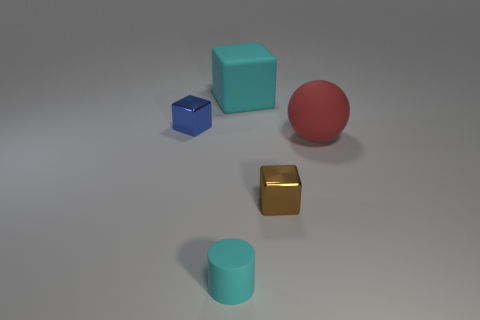Subtract all small cubes. How many cubes are left? 1 Add 4 large rubber objects. How many objects exist? 9 Subtract all cylinders. How many objects are left? 4 Subtract 1 cylinders. How many cylinders are left? 0 Subtract all blue blocks. How many yellow balls are left? 0 Subtract all tiny brown rubber cylinders. Subtract all big matte balls. How many objects are left? 4 Add 5 large cyan rubber cubes. How many large cyan rubber cubes are left? 6 Add 4 cyan matte things. How many cyan matte things exist? 6 Subtract 0 red blocks. How many objects are left? 5 Subtract all purple spheres. Subtract all green blocks. How many spheres are left? 1 